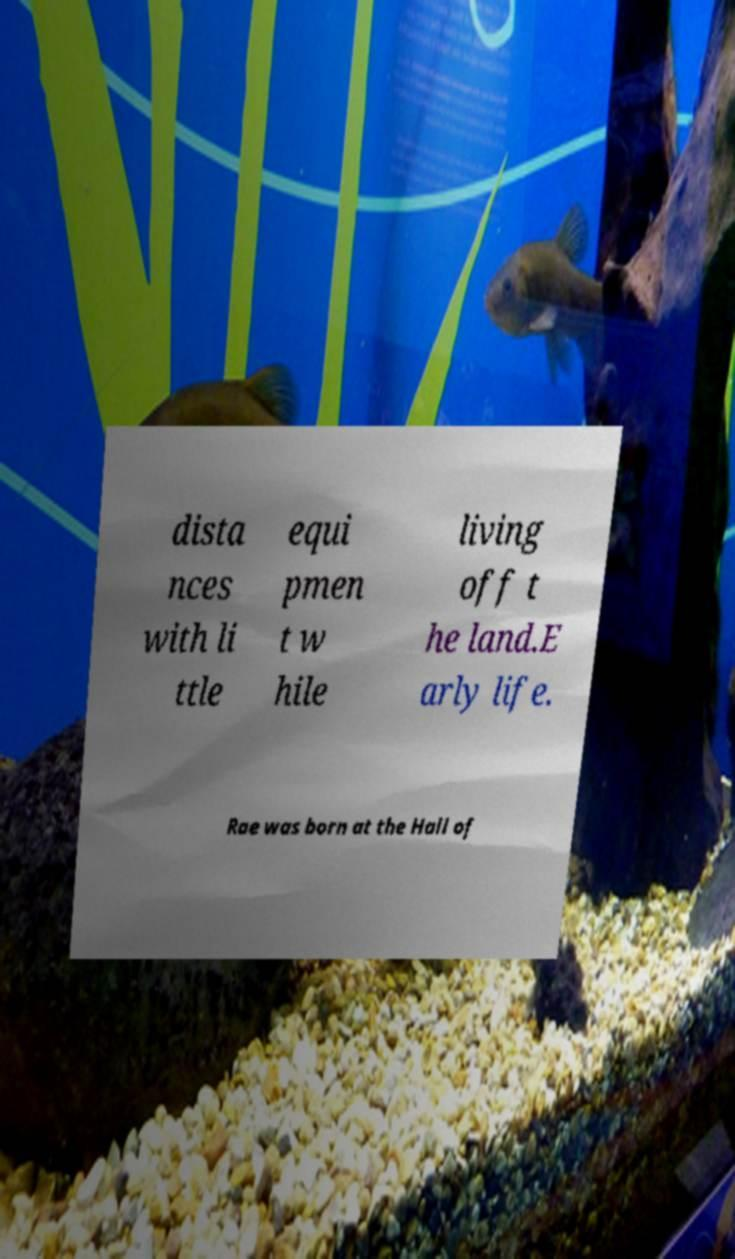Please read and relay the text visible in this image. What does it say? dista nces with li ttle equi pmen t w hile living off t he land.E arly life. Rae was born at the Hall of 